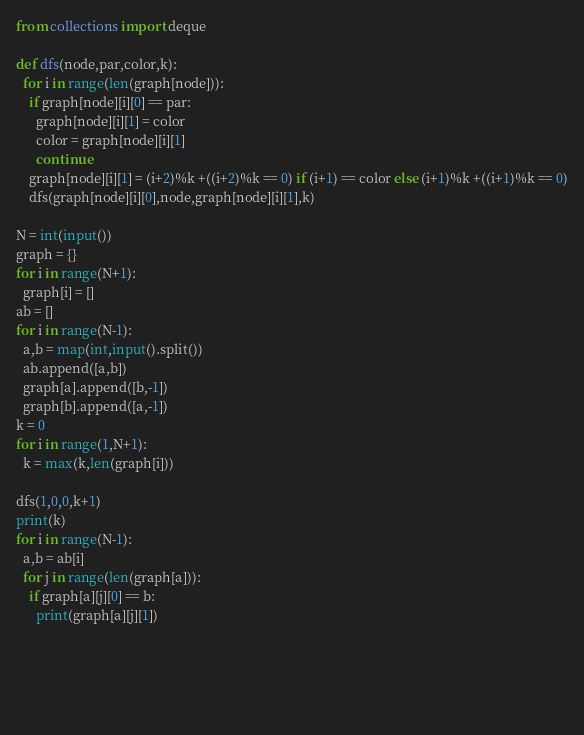<code> <loc_0><loc_0><loc_500><loc_500><_Python_>from collections import deque

def dfs(node,par,color,k):
  for i in range(len(graph[node])):
    if graph[node][i][0] == par:
      graph[node][i][1] = color
      color = graph[node][i][1]       
      continue
    graph[node][i][1] = (i+2)%k +((i+2)%k == 0) if (i+1) == color else (i+1)%k +((i+1)%k == 0)
    dfs(graph[node][i][0],node,graph[node][i][1],k)

N = int(input())
graph = {}
for i in range(N+1):
  graph[i] = []
ab = []
for i in range(N-1):
  a,b = map(int,input().split())
  ab.append([a,b])
  graph[a].append([b,-1])
  graph[b].append([a,-1])
k = 0
for i in range(1,N+1):
  k = max(k,len(graph[i]))

dfs(1,0,0,k+1)
print(k)
for i in range(N-1):
  a,b = ab[i]
  for j in range(len(graph[a])):
    if graph[a][j][0] == b:
      print(graph[a][j][1])

  


  
</code> 